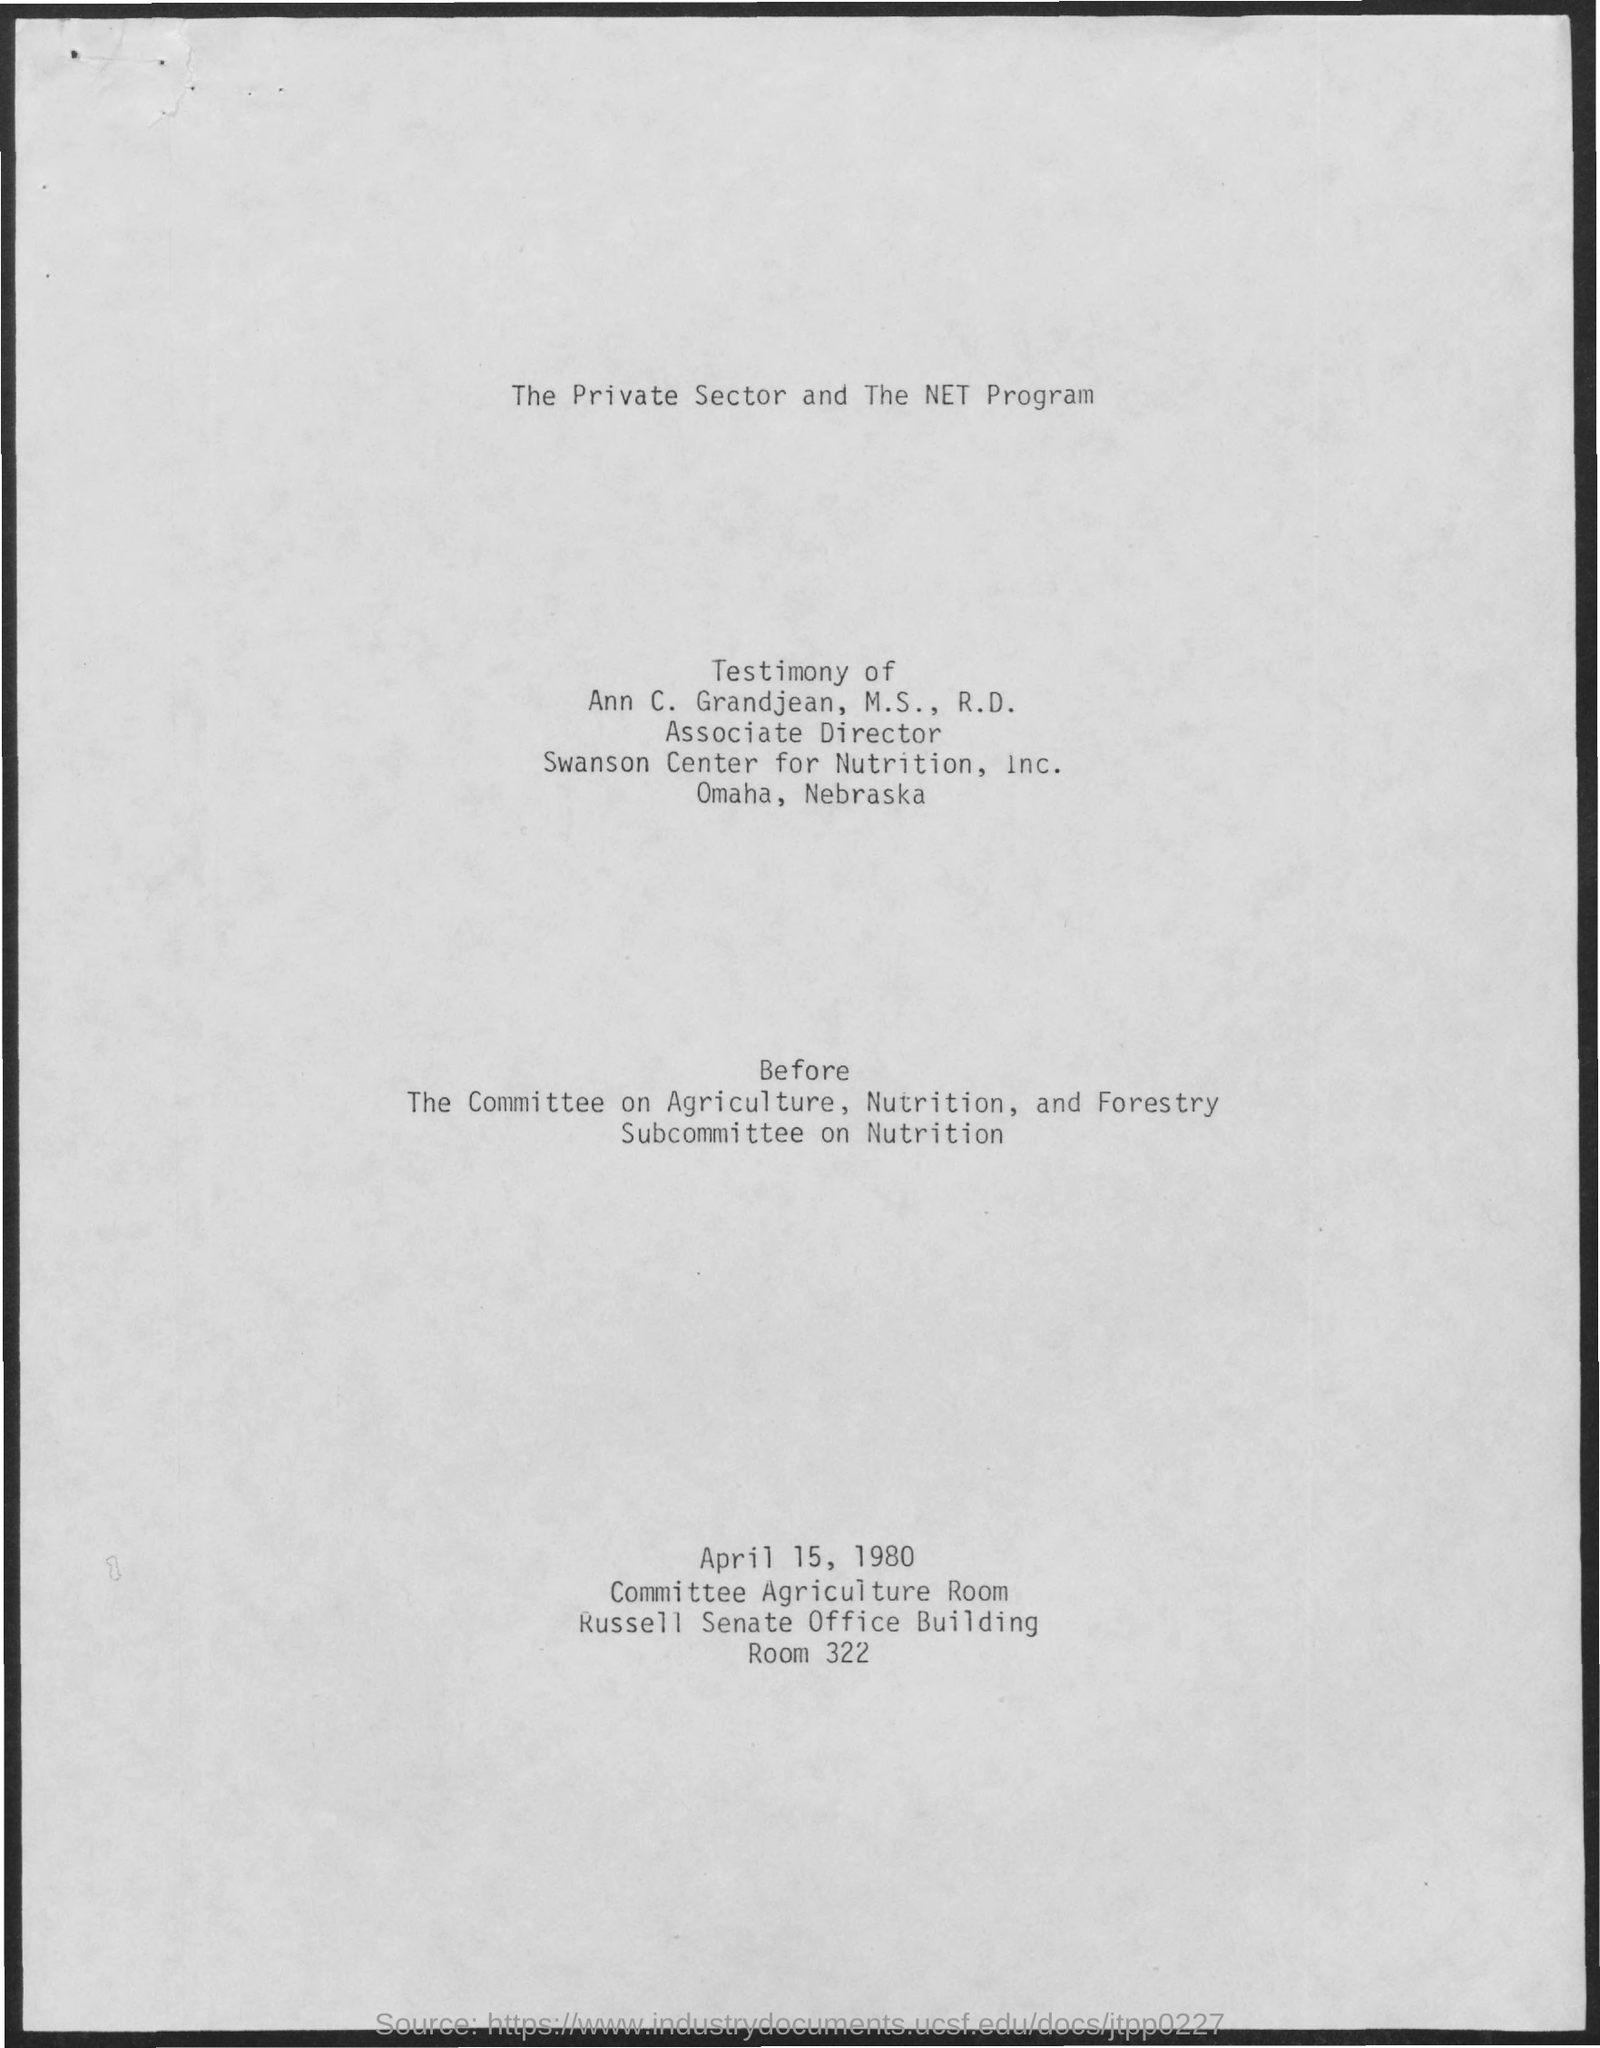Whose testimony is this?
Provide a succinct answer. ANN C. GRANDJEAN. What is the designation of Ann C. Grandjean?
Offer a terse response. Associate Director, Swanson Center for Nutrition, Inc. 